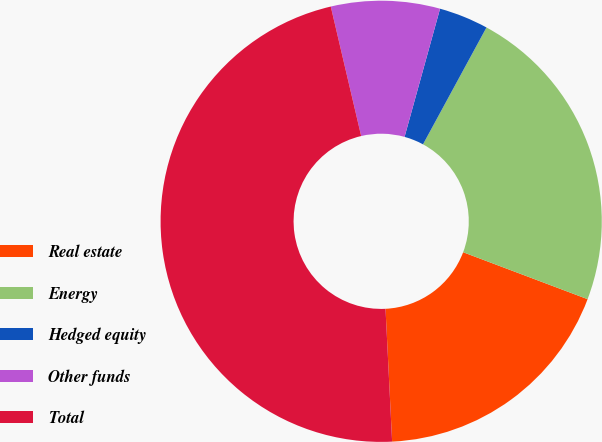<chart> <loc_0><loc_0><loc_500><loc_500><pie_chart><fcel>Real estate<fcel>Energy<fcel>Hedged equity<fcel>Other funds<fcel>Total<nl><fcel>18.47%<fcel>22.82%<fcel>3.62%<fcel>7.97%<fcel>47.12%<nl></chart> 